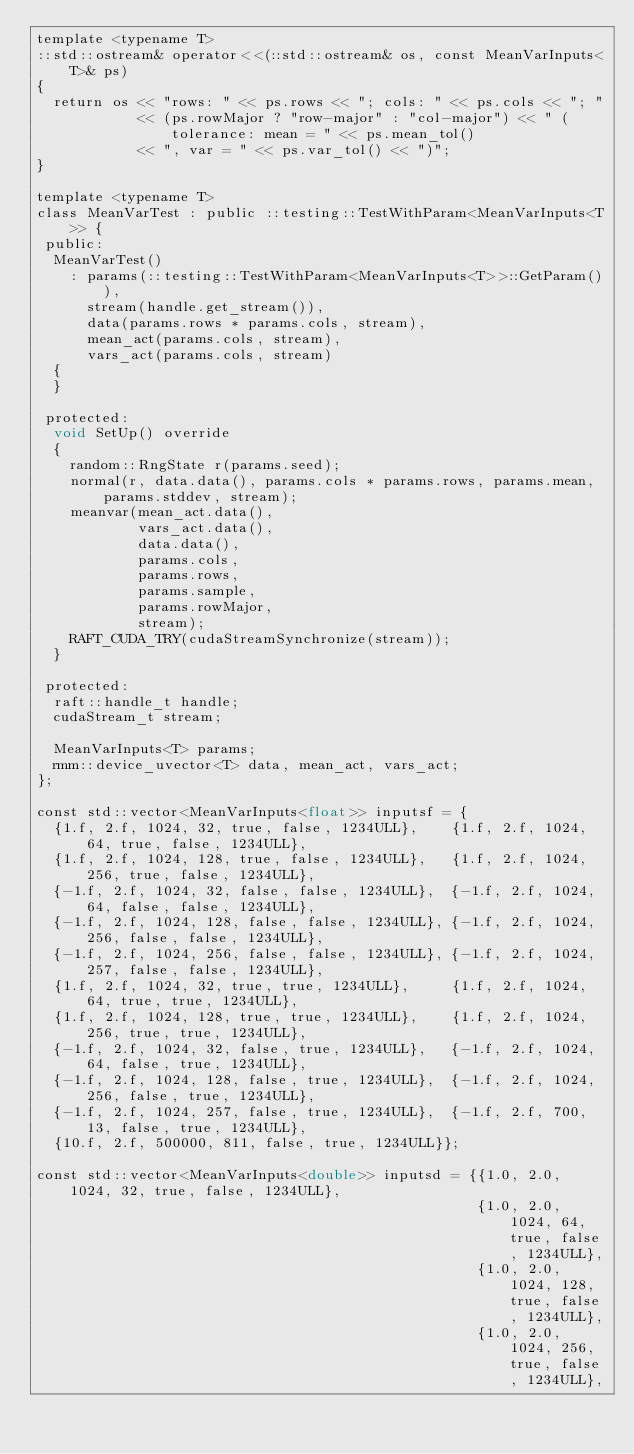Convert code to text. <code><loc_0><loc_0><loc_500><loc_500><_Cuda_>template <typename T>
::std::ostream& operator<<(::std::ostream& os, const MeanVarInputs<T>& ps)
{
  return os << "rows: " << ps.rows << "; cols: " << ps.cols << "; "
            << (ps.rowMajor ? "row-major" : "col-major") << " (tolerance: mean = " << ps.mean_tol()
            << ", var = " << ps.var_tol() << ")";
}

template <typename T>
class MeanVarTest : public ::testing::TestWithParam<MeanVarInputs<T>> {
 public:
  MeanVarTest()
    : params(::testing::TestWithParam<MeanVarInputs<T>>::GetParam()),
      stream(handle.get_stream()),
      data(params.rows * params.cols, stream),
      mean_act(params.cols, stream),
      vars_act(params.cols, stream)
  {
  }

 protected:
  void SetUp() override
  {
    random::RngState r(params.seed);
    normal(r, data.data(), params.cols * params.rows, params.mean, params.stddev, stream);
    meanvar(mean_act.data(),
            vars_act.data(),
            data.data(),
            params.cols,
            params.rows,
            params.sample,
            params.rowMajor,
            stream);
    RAFT_CUDA_TRY(cudaStreamSynchronize(stream));
  }

 protected:
  raft::handle_t handle;
  cudaStream_t stream;

  MeanVarInputs<T> params;
  rmm::device_uvector<T> data, mean_act, vars_act;
};

const std::vector<MeanVarInputs<float>> inputsf = {
  {1.f, 2.f, 1024, 32, true, false, 1234ULL},    {1.f, 2.f, 1024, 64, true, false, 1234ULL},
  {1.f, 2.f, 1024, 128, true, false, 1234ULL},   {1.f, 2.f, 1024, 256, true, false, 1234ULL},
  {-1.f, 2.f, 1024, 32, false, false, 1234ULL},  {-1.f, 2.f, 1024, 64, false, false, 1234ULL},
  {-1.f, 2.f, 1024, 128, false, false, 1234ULL}, {-1.f, 2.f, 1024, 256, false, false, 1234ULL},
  {-1.f, 2.f, 1024, 256, false, false, 1234ULL}, {-1.f, 2.f, 1024, 257, false, false, 1234ULL},
  {1.f, 2.f, 1024, 32, true, true, 1234ULL},     {1.f, 2.f, 1024, 64, true, true, 1234ULL},
  {1.f, 2.f, 1024, 128, true, true, 1234ULL},    {1.f, 2.f, 1024, 256, true, true, 1234ULL},
  {-1.f, 2.f, 1024, 32, false, true, 1234ULL},   {-1.f, 2.f, 1024, 64, false, true, 1234ULL},
  {-1.f, 2.f, 1024, 128, false, true, 1234ULL},  {-1.f, 2.f, 1024, 256, false, true, 1234ULL},
  {-1.f, 2.f, 1024, 257, false, true, 1234ULL},  {-1.f, 2.f, 700, 13, false, true, 1234ULL},
  {10.f, 2.f, 500000, 811, false, true, 1234ULL}};

const std::vector<MeanVarInputs<double>> inputsd = {{1.0, 2.0, 1024, 32, true, false, 1234ULL},
                                                    {1.0, 2.0, 1024, 64, true, false, 1234ULL},
                                                    {1.0, 2.0, 1024, 128, true, false, 1234ULL},
                                                    {1.0, 2.0, 1024, 256, true, false, 1234ULL},</code> 